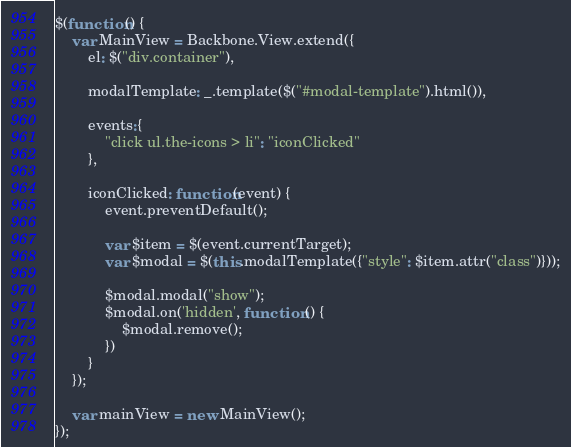Convert code to text. <code><loc_0><loc_0><loc_500><loc_500><_JavaScript_>$(function() {
    var MainView = Backbone.View.extend({
        el: $("div.container"),

        modalTemplate: _.template($("#modal-template").html()),

        events:{
            "click ul.the-icons > li": "iconClicked"
        },

        iconClicked: function(event) {
            event.preventDefault();

            var $item = $(event.currentTarget);
            var $modal = $(this.modalTemplate({"style": $item.attr("class")}));

            $modal.modal("show");
            $modal.on('hidden', function () {
                $modal.remove();
            })
        }
    });

    var mainView = new MainView();
});
</code> 